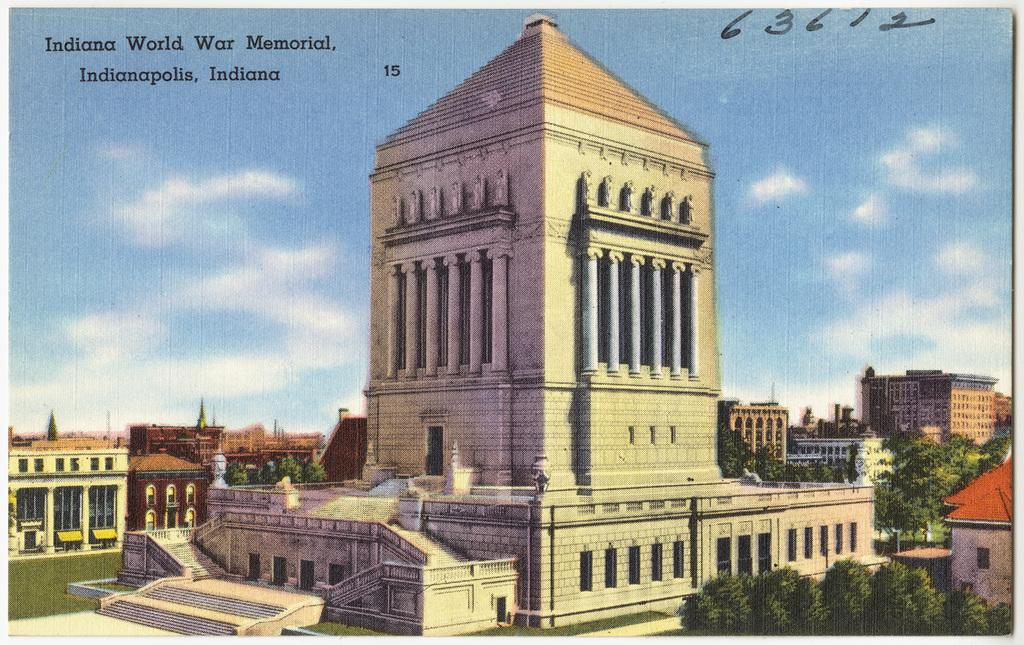<image>
Present a compact description of the photo's key features. The memorial in the painting is from Indiana 